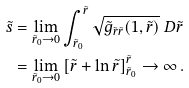<formula> <loc_0><loc_0><loc_500><loc_500>\tilde { s } & = \lim _ { \tilde { r } _ { 0 } \to 0 } \int ^ { \tilde { r } } _ { \tilde { r } _ { 0 } } \sqrt { \tilde { g } _ { \tilde { r } \tilde { r } } ( 1 , \tilde { r } ) } \ D \tilde { r } \\ & = \lim _ { \tilde { r } _ { 0 } \to 0 } \left [ \tilde { r } + \ln \tilde { r } \right ] _ { \tilde { r } _ { 0 } } ^ { \tilde { r } } \to \infty \, .</formula> 